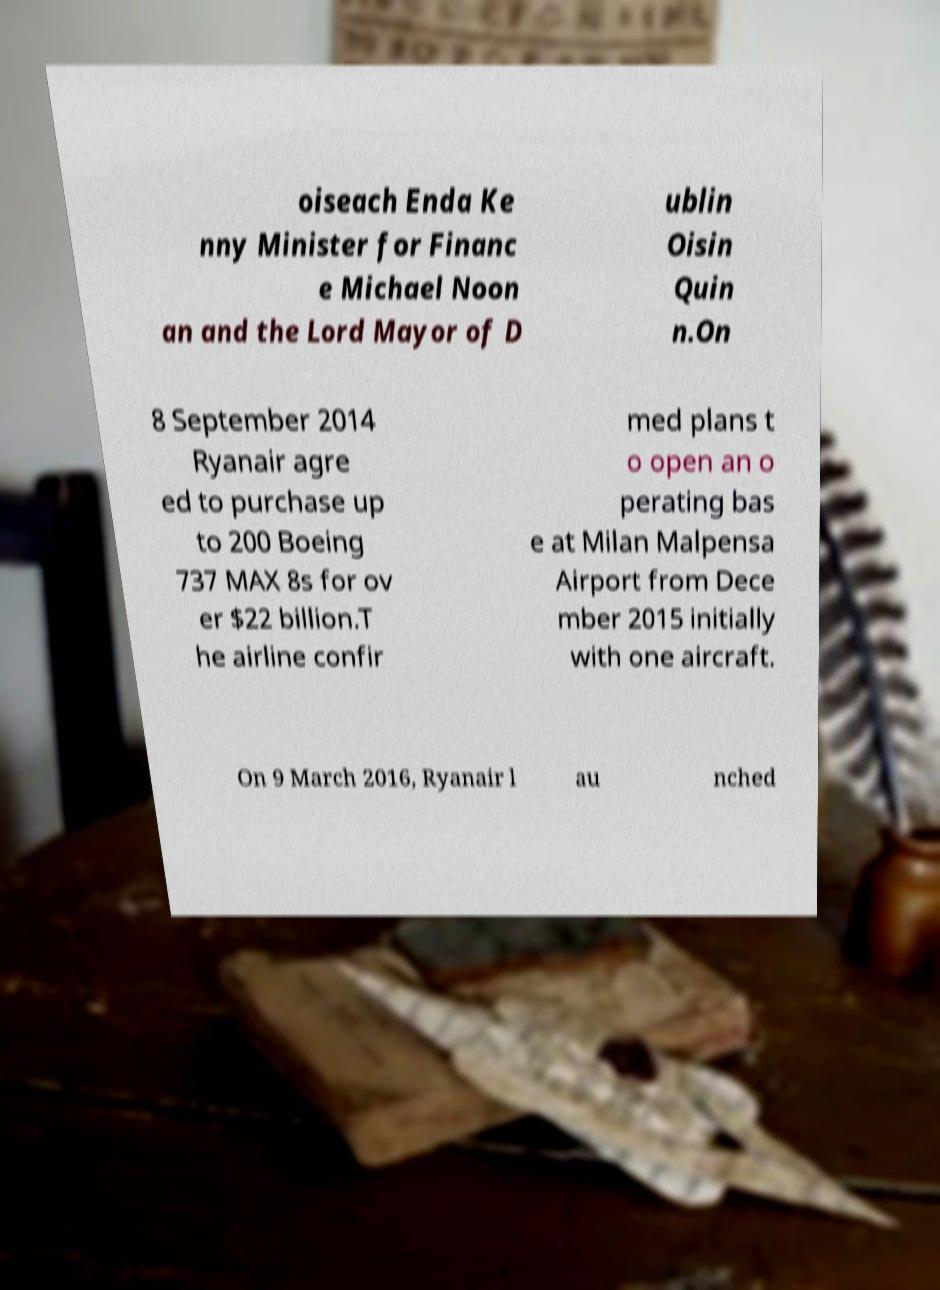There's text embedded in this image that I need extracted. Can you transcribe it verbatim? oiseach Enda Ke nny Minister for Financ e Michael Noon an and the Lord Mayor of D ublin Oisin Quin n.On 8 September 2014 Ryanair agre ed to purchase up to 200 Boeing 737 MAX 8s for ov er $22 billion.T he airline confir med plans t o open an o perating bas e at Milan Malpensa Airport from Dece mber 2015 initially with one aircraft. On 9 March 2016, Ryanair l au nched 